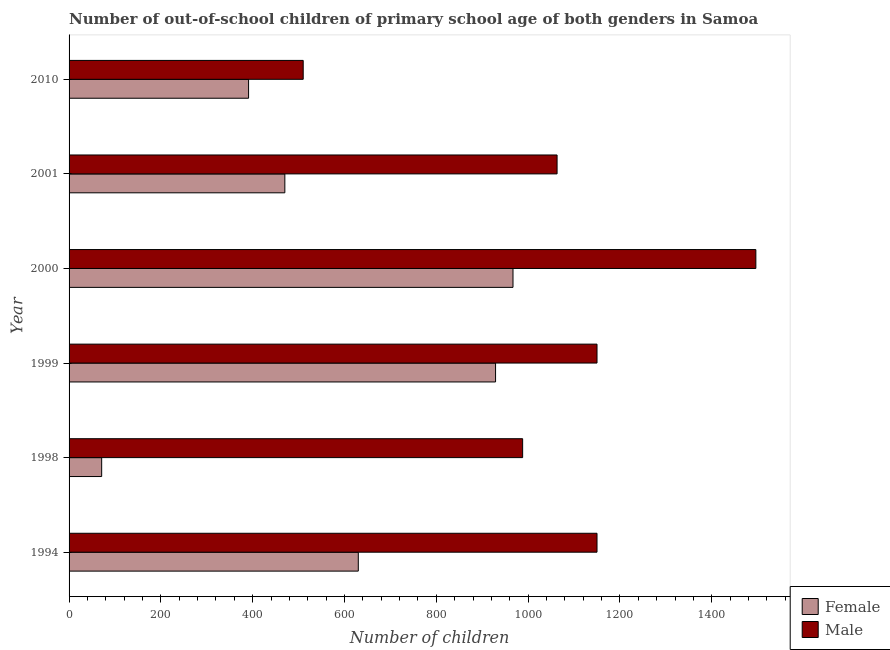Are the number of bars per tick equal to the number of legend labels?
Your answer should be very brief. Yes. Are the number of bars on each tick of the Y-axis equal?
Give a very brief answer. Yes. In how many cases, is the number of bars for a given year not equal to the number of legend labels?
Make the answer very short. 0. What is the number of male out-of-school students in 1998?
Provide a succinct answer. 988. Across all years, what is the maximum number of female out-of-school students?
Your answer should be compact. 967. Across all years, what is the minimum number of male out-of-school students?
Keep it short and to the point. 510. In which year was the number of male out-of-school students maximum?
Provide a short and direct response. 2000. What is the total number of male out-of-school students in the graph?
Offer a terse response. 6357. What is the difference between the number of male out-of-school students in 1998 and that in 2000?
Ensure brevity in your answer.  -508. What is the difference between the number of male out-of-school students in 1998 and the number of female out-of-school students in 1999?
Offer a terse response. 59. What is the average number of male out-of-school students per year?
Make the answer very short. 1059.5. In the year 2001, what is the difference between the number of male out-of-school students and number of female out-of-school students?
Provide a short and direct response. 593. What is the ratio of the number of male out-of-school students in 1994 to that in 2000?
Offer a very short reply. 0.77. Is the number of female out-of-school students in 1998 less than that in 2000?
Offer a very short reply. Yes. What is the difference between the highest and the second highest number of male out-of-school students?
Offer a very short reply. 346. What is the difference between the highest and the lowest number of female out-of-school students?
Offer a terse response. 896. In how many years, is the number of male out-of-school students greater than the average number of male out-of-school students taken over all years?
Provide a succinct answer. 4. Is the sum of the number of female out-of-school students in 1994 and 1998 greater than the maximum number of male out-of-school students across all years?
Provide a succinct answer. No. What does the 2nd bar from the top in 2010 represents?
Your answer should be compact. Female. What does the 1st bar from the bottom in 2000 represents?
Your response must be concise. Female. Are all the bars in the graph horizontal?
Ensure brevity in your answer.  Yes. What is the difference between two consecutive major ticks on the X-axis?
Your response must be concise. 200. Are the values on the major ticks of X-axis written in scientific E-notation?
Give a very brief answer. No. Where does the legend appear in the graph?
Your response must be concise. Bottom right. What is the title of the graph?
Make the answer very short. Number of out-of-school children of primary school age of both genders in Samoa. What is the label or title of the X-axis?
Provide a succinct answer. Number of children. What is the label or title of the Y-axis?
Your answer should be very brief. Year. What is the Number of children in Female in 1994?
Offer a very short reply. 630. What is the Number of children in Male in 1994?
Offer a very short reply. 1150. What is the Number of children of Female in 1998?
Give a very brief answer. 71. What is the Number of children in Male in 1998?
Ensure brevity in your answer.  988. What is the Number of children of Female in 1999?
Make the answer very short. 929. What is the Number of children of Male in 1999?
Your answer should be compact. 1150. What is the Number of children of Female in 2000?
Provide a succinct answer. 967. What is the Number of children in Male in 2000?
Your response must be concise. 1496. What is the Number of children of Female in 2001?
Keep it short and to the point. 470. What is the Number of children of Male in 2001?
Offer a terse response. 1063. What is the Number of children of Female in 2010?
Ensure brevity in your answer.  391. What is the Number of children in Male in 2010?
Ensure brevity in your answer.  510. Across all years, what is the maximum Number of children of Female?
Your answer should be very brief. 967. Across all years, what is the maximum Number of children of Male?
Ensure brevity in your answer.  1496. Across all years, what is the minimum Number of children in Female?
Offer a very short reply. 71. Across all years, what is the minimum Number of children in Male?
Offer a terse response. 510. What is the total Number of children of Female in the graph?
Provide a succinct answer. 3458. What is the total Number of children in Male in the graph?
Offer a terse response. 6357. What is the difference between the Number of children of Female in 1994 and that in 1998?
Your answer should be very brief. 559. What is the difference between the Number of children in Male in 1994 and that in 1998?
Your response must be concise. 162. What is the difference between the Number of children in Female in 1994 and that in 1999?
Your answer should be very brief. -299. What is the difference between the Number of children of Female in 1994 and that in 2000?
Your answer should be very brief. -337. What is the difference between the Number of children in Male in 1994 and that in 2000?
Provide a succinct answer. -346. What is the difference between the Number of children of Female in 1994 and that in 2001?
Keep it short and to the point. 160. What is the difference between the Number of children in Male in 1994 and that in 2001?
Offer a very short reply. 87. What is the difference between the Number of children in Female in 1994 and that in 2010?
Your response must be concise. 239. What is the difference between the Number of children in Male in 1994 and that in 2010?
Offer a very short reply. 640. What is the difference between the Number of children of Female in 1998 and that in 1999?
Provide a succinct answer. -858. What is the difference between the Number of children of Male in 1998 and that in 1999?
Keep it short and to the point. -162. What is the difference between the Number of children of Female in 1998 and that in 2000?
Your answer should be compact. -896. What is the difference between the Number of children in Male in 1998 and that in 2000?
Provide a short and direct response. -508. What is the difference between the Number of children in Female in 1998 and that in 2001?
Offer a very short reply. -399. What is the difference between the Number of children in Male in 1998 and that in 2001?
Your response must be concise. -75. What is the difference between the Number of children in Female in 1998 and that in 2010?
Your answer should be compact. -320. What is the difference between the Number of children of Male in 1998 and that in 2010?
Your answer should be compact. 478. What is the difference between the Number of children of Female in 1999 and that in 2000?
Make the answer very short. -38. What is the difference between the Number of children of Male in 1999 and that in 2000?
Offer a very short reply. -346. What is the difference between the Number of children of Female in 1999 and that in 2001?
Offer a terse response. 459. What is the difference between the Number of children of Male in 1999 and that in 2001?
Offer a terse response. 87. What is the difference between the Number of children of Female in 1999 and that in 2010?
Your answer should be very brief. 538. What is the difference between the Number of children of Male in 1999 and that in 2010?
Provide a short and direct response. 640. What is the difference between the Number of children in Female in 2000 and that in 2001?
Offer a terse response. 497. What is the difference between the Number of children of Male in 2000 and that in 2001?
Offer a terse response. 433. What is the difference between the Number of children in Female in 2000 and that in 2010?
Your answer should be very brief. 576. What is the difference between the Number of children in Male in 2000 and that in 2010?
Offer a very short reply. 986. What is the difference between the Number of children of Female in 2001 and that in 2010?
Make the answer very short. 79. What is the difference between the Number of children in Male in 2001 and that in 2010?
Ensure brevity in your answer.  553. What is the difference between the Number of children in Female in 1994 and the Number of children in Male in 1998?
Give a very brief answer. -358. What is the difference between the Number of children in Female in 1994 and the Number of children in Male in 1999?
Ensure brevity in your answer.  -520. What is the difference between the Number of children in Female in 1994 and the Number of children in Male in 2000?
Make the answer very short. -866. What is the difference between the Number of children in Female in 1994 and the Number of children in Male in 2001?
Offer a very short reply. -433. What is the difference between the Number of children in Female in 1994 and the Number of children in Male in 2010?
Offer a very short reply. 120. What is the difference between the Number of children of Female in 1998 and the Number of children of Male in 1999?
Your answer should be very brief. -1079. What is the difference between the Number of children in Female in 1998 and the Number of children in Male in 2000?
Keep it short and to the point. -1425. What is the difference between the Number of children in Female in 1998 and the Number of children in Male in 2001?
Give a very brief answer. -992. What is the difference between the Number of children in Female in 1998 and the Number of children in Male in 2010?
Provide a short and direct response. -439. What is the difference between the Number of children in Female in 1999 and the Number of children in Male in 2000?
Provide a succinct answer. -567. What is the difference between the Number of children in Female in 1999 and the Number of children in Male in 2001?
Your answer should be very brief. -134. What is the difference between the Number of children of Female in 1999 and the Number of children of Male in 2010?
Offer a very short reply. 419. What is the difference between the Number of children in Female in 2000 and the Number of children in Male in 2001?
Offer a very short reply. -96. What is the difference between the Number of children in Female in 2000 and the Number of children in Male in 2010?
Your response must be concise. 457. What is the average Number of children of Female per year?
Provide a succinct answer. 576.33. What is the average Number of children in Male per year?
Your response must be concise. 1059.5. In the year 1994, what is the difference between the Number of children in Female and Number of children in Male?
Give a very brief answer. -520. In the year 1998, what is the difference between the Number of children of Female and Number of children of Male?
Provide a short and direct response. -917. In the year 1999, what is the difference between the Number of children of Female and Number of children of Male?
Provide a short and direct response. -221. In the year 2000, what is the difference between the Number of children in Female and Number of children in Male?
Your response must be concise. -529. In the year 2001, what is the difference between the Number of children in Female and Number of children in Male?
Provide a succinct answer. -593. In the year 2010, what is the difference between the Number of children in Female and Number of children in Male?
Offer a terse response. -119. What is the ratio of the Number of children of Female in 1994 to that in 1998?
Give a very brief answer. 8.87. What is the ratio of the Number of children in Male in 1994 to that in 1998?
Provide a succinct answer. 1.16. What is the ratio of the Number of children in Female in 1994 to that in 1999?
Keep it short and to the point. 0.68. What is the ratio of the Number of children of Male in 1994 to that in 1999?
Offer a very short reply. 1. What is the ratio of the Number of children in Female in 1994 to that in 2000?
Your answer should be very brief. 0.65. What is the ratio of the Number of children in Male in 1994 to that in 2000?
Offer a terse response. 0.77. What is the ratio of the Number of children in Female in 1994 to that in 2001?
Keep it short and to the point. 1.34. What is the ratio of the Number of children in Male in 1994 to that in 2001?
Your response must be concise. 1.08. What is the ratio of the Number of children in Female in 1994 to that in 2010?
Keep it short and to the point. 1.61. What is the ratio of the Number of children in Male in 1994 to that in 2010?
Your response must be concise. 2.25. What is the ratio of the Number of children in Female in 1998 to that in 1999?
Give a very brief answer. 0.08. What is the ratio of the Number of children in Male in 1998 to that in 1999?
Give a very brief answer. 0.86. What is the ratio of the Number of children in Female in 1998 to that in 2000?
Offer a terse response. 0.07. What is the ratio of the Number of children of Male in 1998 to that in 2000?
Give a very brief answer. 0.66. What is the ratio of the Number of children of Female in 1998 to that in 2001?
Keep it short and to the point. 0.15. What is the ratio of the Number of children in Male in 1998 to that in 2001?
Your response must be concise. 0.93. What is the ratio of the Number of children in Female in 1998 to that in 2010?
Give a very brief answer. 0.18. What is the ratio of the Number of children of Male in 1998 to that in 2010?
Your answer should be very brief. 1.94. What is the ratio of the Number of children in Female in 1999 to that in 2000?
Keep it short and to the point. 0.96. What is the ratio of the Number of children of Male in 1999 to that in 2000?
Give a very brief answer. 0.77. What is the ratio of the Number of children in Female in 1999 to that in 2001?
Provide a succinct answer. 1.98. What is the ratio of the Number of children in Male in 1999 to that in 2001?
Keep it short and to the point. 1.08. What is the ratio of the Number of children in Female in 1999 to that in 2010?
Make the answer very short. 2.38. What is the ratio of the Number of children in Male in 1999 to that in 2010?
Provide a succinct answer. 2.25. What is the ratio of the Number of children in Female in 2000 to that in 2001?
Keep it short and to the point. 2.06. What is the ratio of the Number of children of Male in 2000 to that in 2001?
Offer a terse response. 1.41. What is the ratio of the Number of children in Female in 2000 to that in 2010?
Provide a succinct answer. 2.47. What is the ratio of the Number of children of Male in 2000 to that in 2010?
Make the answer very short. 2.93. What is the ratio of the Number of children in Female in 2001 to that in 2010?
Provide a short and direct response. 1.2. What is the ratio of the Number of children in Male in 2001 to that in 2010?
Your response must be concise. 2.08. What is the difference between the highest and the second highest Number of children in Female?
Your answer should be very brief. 38. What is the difference between the highest and the second highest Number of children in Male?
Your response must be concise. 346. What is the difference between the highest and the lowest Number of children of Female?
Your answer should be very brief. 896. What is the difference between the highest and the lowest Number of children of Male?
Offer a very short reply. 986. 